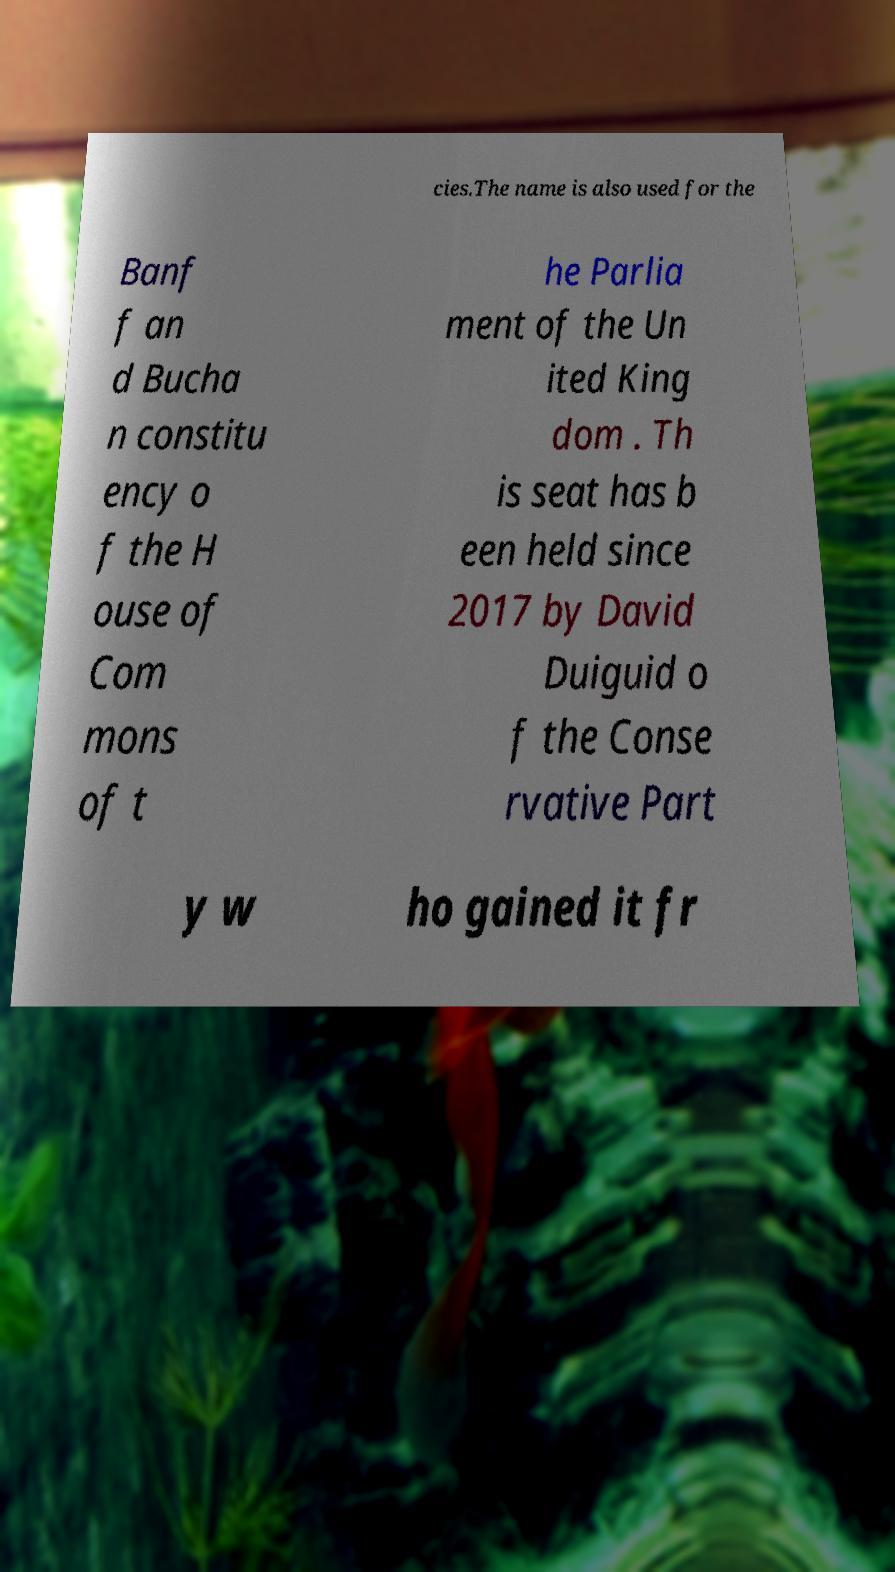Can you accurately transcribe the text from the provided image for me? cies.The name is also used for the Banf f an d Bucha n constitu ency o f the H ouse of Com mons of t he Parlia ment of the Un ited King dom . Th is seat has b een held since 2017 by David Duiguid o f the Conse rvative Part y w ho gained it fr 